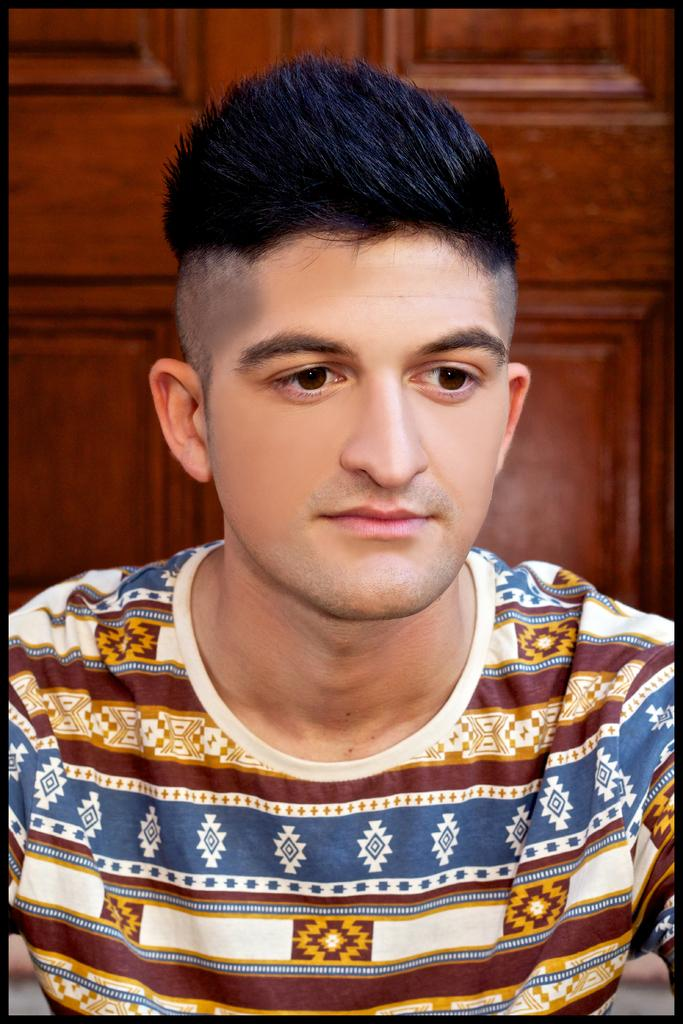What is the main subject of the image? There is a man in the image. What type of cattle can be seen grazing on the stage in the image? There is no stage, cattle, or smoke present in the image; it only features a man. 